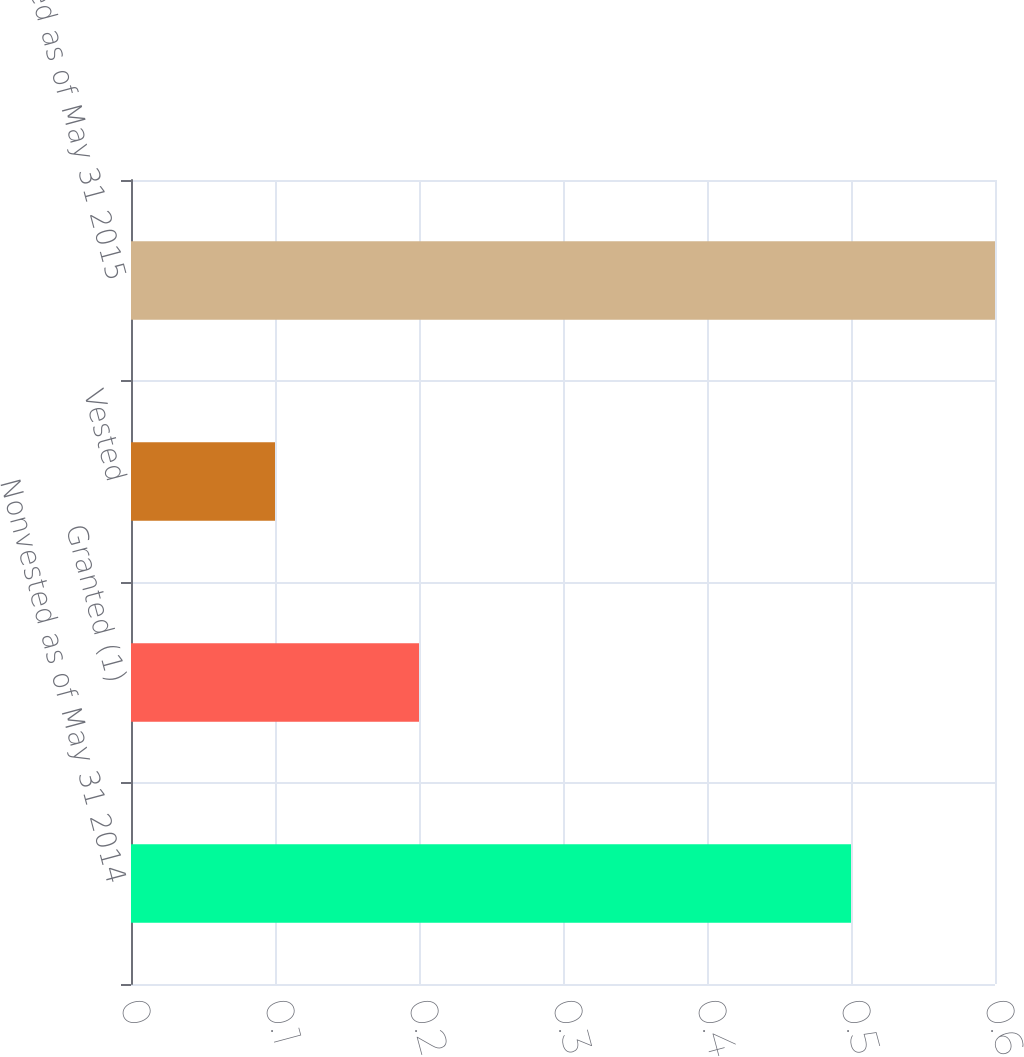Convert chart. <chart><loc_0><loc_0><loc_500><loc_500><bar_chart><fcel>Nonvested as of May 31 2014<fcel>Granted (1)<fcel>Vested<fcel>Nonvested as of May 31 2015<nl><fcel>0.5<fcel>0.2<fcel>0.1<fcel>0.6<nl></chart> 